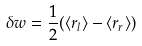<formula> <loc_0><loc_0><loc_500><loc_500>\delta w = \frac { 1 } { 2 } ( \langle r _ { l } \rangle - \langle r _ { r } \rangle )</formula> 